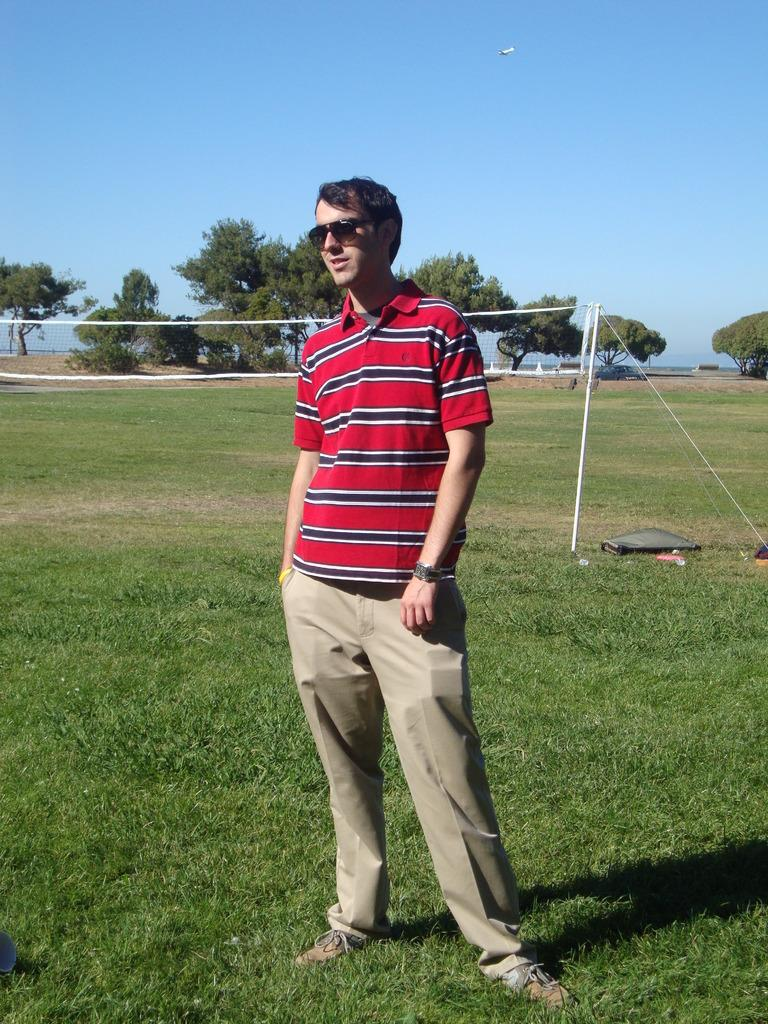What is the main subject of the image? There is a man standing in the image. What is the man wearing in the image? The man is wearing sunglasses. What can be seen attached to a pole in the image? There is a net attached to a pole in the image. What type of surface is under the man's feet? Grass is present on the ground. What is visible in the background of the image? There are trees in the background of the image. How would you describe the sky in the image? The sky is blue and cloudy. What type of vegetable is the man holding in the image? There is no vegetable present in the image; the man is not holding anything. What is the relation between the man and the trees in the background? There is no indication of a relation between the man and the trees in the image. 